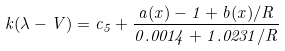Convert formula to latex. <formula><loc_0><loc_0><loc_500><loc_500>k ( \lambda - V ) = c _ { 5 } + \frac { a ( x ) - 1 + b ( x ) / R } { 0 . 0 0 1 4 + 1 . 0 2 3 1 / R }</formula> 